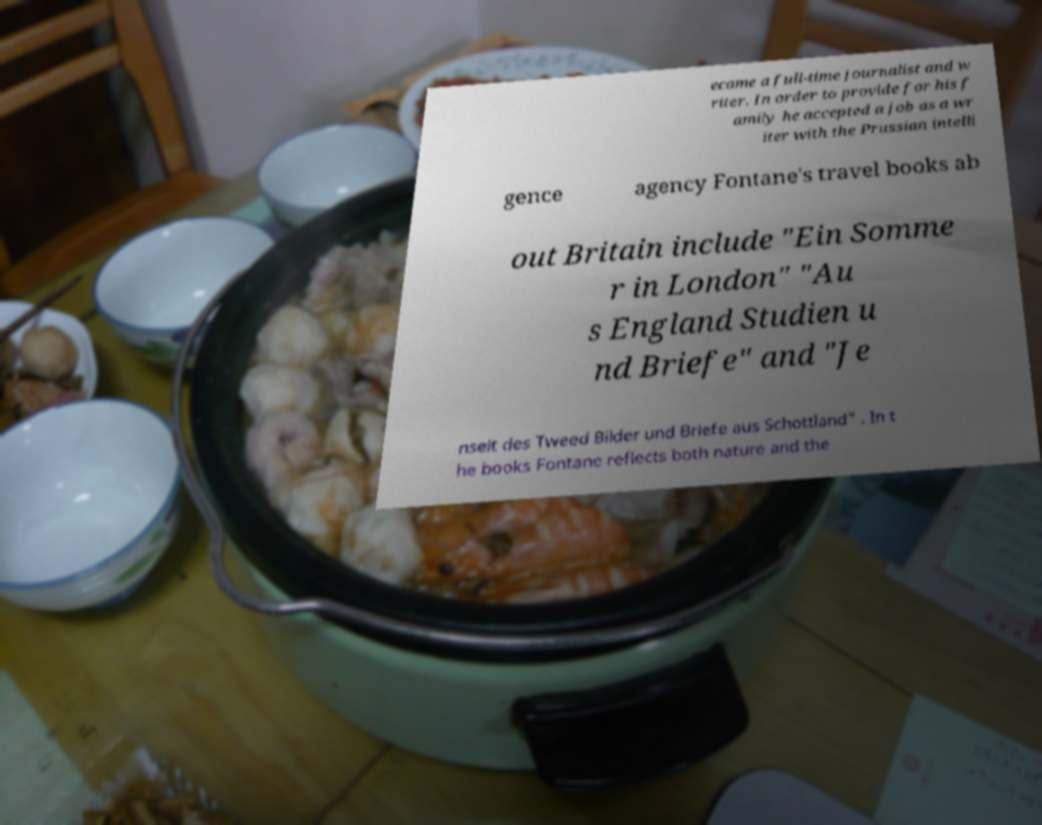Can you read and provide the text displayed in the image?This photo seems to have some interesting text. Can you extract and type it out for me? ecame a full-time journalist and w riter. In order to provide for his f amily he accepted a job as a wr iter with the Prussian intelli gence agency Fontane's travel books ab out Britain include "Ein Somme r in London" "Au s England Studien u nd Briefe" and "Je nseit des Tweed Bilder und Briefe aus Schottland" . In t he books Fontane reflects both nature and the 